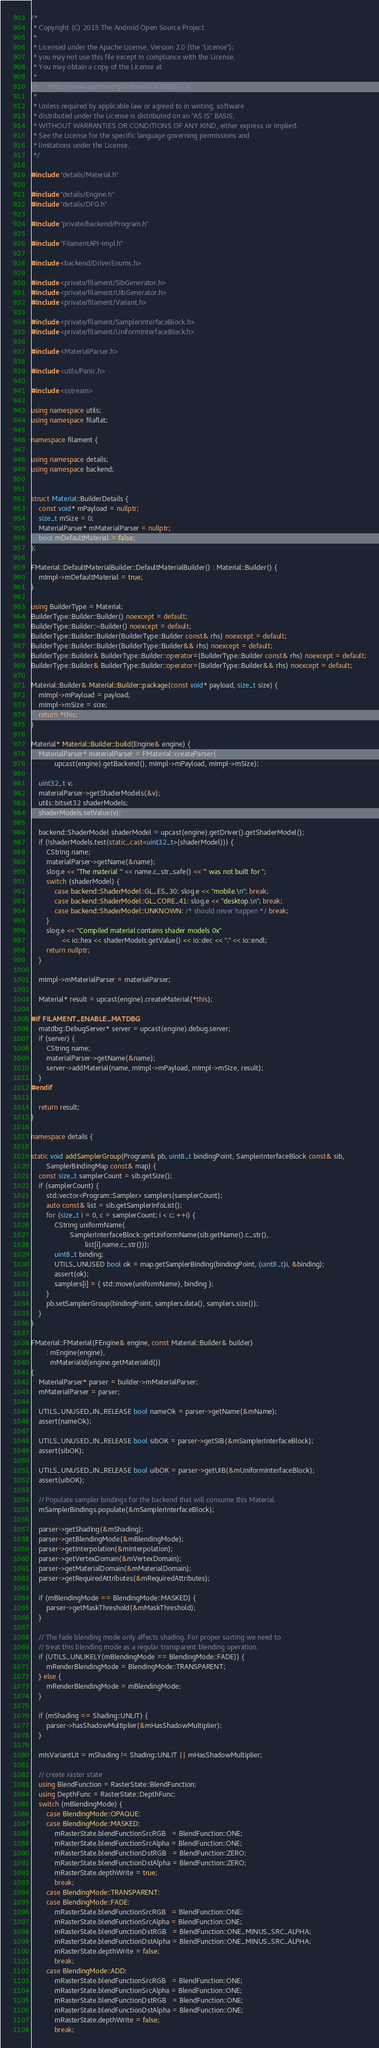<code> <loc_0><loc_0><loc_500><loc_500><_C++_>/*
 * Copyright (C) 2015 The Android Open Source Project
 *
 * Licensed under the Apache License, Version 2.0 (the "License");
 * you may not use this file except in compliance with the License.
 * You may obtain a copy of the License at
 *
 *      http://www.apache.org/licenses/LICENSE-2.0
 *
 * Unless required by applicable law or agreed to in writing, software
 * distributed under the License is distributed on an "AS IS" BASIS,
 * WITHOUT WARRANTIES OR CONDITIONS OF ANY KIND, either express or implied.
 * See the License for the specific language governing permissions and
 * limitations under the License.
 */

#include "details/Material.h"

#include "details/Engine.h"
#include "details/DFG.h"

#include "private/backend/Program.h"

#include "FilamentAPI-impl.h"

#include <backend/DriverEnums.h>

#include <private/filament/SibGenerator.h>
#include <private/filament/UibGenerator.h>
#include <private/filament/Variant.h>

#include <private/filament/SamplerInterfaceBlock.h>
#include <private/filament/UniformInterfaceBlock.h>

#include <MaterialParser.h>

#include <utils/Panic.h>

#include <sstream>

using namespace utils;
using namespace filaflat;

namespace filament {

using namespace details;
using namespace backend;


struct Material::BuilderDetails {
    const void* mPayload = nullptr;
    size_t mSize = 0;
    MaterialParser* mMaterialParser = nullptr;
    bool mDefaultMaterial = false;
};

FMaterial::DefaultMaterialBuilder::DefaultMaterialBuilder() : Material::Builder() {
    mImpl->mDefaultMaterial = true;
}

using BuilderType = Material;
BuilderType::Builder::Builder() noexcept = default;
BuilderType::Builder::~Builder() noexcept = default;
BuilderType::Builder::Builder(BuilderType::Builder const& rhs) noexcept = default;
BuilderType::Builder::Builder(BuilderType::Builder&& rhs) noexcept = default;
BuilderType::Builder& BuilderType::Builder::operator=(BuilderType::Builder const& rhs) noexcept = default;
BuilderType::Builder& BuilderType::Builder::operator=(BuilderType::Builder&& rhs) noexcept = default;

Material::Builder& Material::Builder::package(const void* payload, size_t size) {
    mImpl->mPayload = payload;
    mImpl->mSize = size;
    return *this;
}

Material* Material::Builder::build(Engine& engine) {
    MaterialParser* materialParser = FMaterial::createParser(
            upcast(engine).getBackend(), mImpl->mPayload, mImpl->mSize);

    uint32_t v;
    materialParser->getShaderModels(&v);
    utils::bitset32 shaderModels;
    shaderModels.setValue(v);

    backend::ShaderModel shaderModel = upcast(engine).getDriver().getShaderModel();
    if (!shaderModels.test(static_cast<uint32_t>(shaderModel))) {
        CString name;
        materialParser->getName(&name);
        slog.e << "The material '" << name.c_str_safe() << "' was not built for ";
        switch (shaderModel) {
            case backend::ShaderModel::GL_ES_30: slog.e << "mobile.\n"; break;
            case backend::ShaderModel::GL_CORE_41: slog.e << "desktop.\n"; break;
            case backend::ShaderModel::UNKNOWN: /* should never happen */ break;
        }
        slog.e << "Compiled material contains shader models 0x"
                << io::hex << shaderModels.getValue() << io::dec << "." << io::endl;
        return nullptr;
    }

    mImpl->mMaterialParser = materialParser;

    Material* result = upcast(engine).createMaterial(*this);

#if FILAMENT_ENABLE_MATDBG
    matdbg::DebugServer* server = upcast(engine).debug.server;
    if (server) {
        CString name;
        materialParser->getName(&name);
        server->addMaterial(name, mImpl->mPayload, mImpl->mSize, result);
    }
#endif

    return result;
}

namespace details {

static void addSamplerGroup(Program& pb, uint8_t bindingPoint, SamplerInterfaceBlock const& sib,
        SamplerBindingMap const& map) {
    const size_t samplerCount = sib.getSize();
    if (samplerCount) {
        std::vector<Program::Sampler> samplers(samplerCount);
        auto const& list = sib.getSamplerInfoList();
        for (size_t i = 0, c = samplerCount; i < c; ++i) {
            CString uniformName(
                    SamplerInterfaceBlock::getUniformName(sib.getName().c_str(),
                            list[i].name.c_str()));
            uint8_t binding;
            UTILS_UNUSED bool ok = map.getSamplerBinding(bindingPoint, (uint8_t)i, &binding);
            assert(ok);
            samplers[i] = { std::move(uniformName), binding };
        }
        pb.setSamplerGroup(bindingPoint, samplers.data(), samplers.size());
    }
}

FMaterial::FMaterial(FEngine& engine, const Material::Builder& builder)
        : mEngine(engine),
          mMaterialId(engine.getMaterialId())
{
    MaterialParser* parser = builder->mMaterialParser;
    mMaterialParser = parser;

    UTILS_UNUSED_IN_RELEASE bool nameOk = parser->getName(&mName);
    assert(nameOk);

    UTILS_UNUSED_IN_RELEASE bool sibOK = parser->getSIB(&mSamplerInterfaceBlock);
    assert(sibOK);

    UTILS_UNUSED_IN_RELEASE bool uibOK = parser->getUIB(&mUniformInterfaceBlock);
    assert(uibOK);

    // Populate sampler bindings for the backend that will consume this Material.
    mSamplerBindings.populate(&mSamplerInterfaceBlock);

    parser->getShading(&mShading);
    parser->getBlendingMode(&mBlendingMode);
    parser->getInterpolation(&mInterpolation);
    parser->getVertexDomain(&mVertexDomain);
    parser->getMaterialDomain(&mMaterialDomain);
    parser->getRequiredAttributes(&mRequiredAttributes);

    if (mBlendingMode == BlendingMode::MASKED) {
        parser->getMaskThreshold(&mMaskThreshold);
    }

    // The fade blending mode only affects shading. For proper sorting we need to
    // treat this blending mode as a regular transparent blending operation.
    if (UTILS_UNLIKELY(mBlendingMode == BlendingMode::FADE)) {
        mRenderBlendingMode = BlendingMode::TRANSPARENT;
    } else {
        mRenderBlendingMode = mBlendingMode;
    }

    if (mShading == Shading::UNLIT) {
        parser->hasShadowMultiplier(&mHasShadowMultiplier);
    }

    mIsVariantLit = mShading != Shading::UNLIT || mHasShadowMultiplier;

    // create raster state
    using BlendFunction = RasterState::BlendFunction;
    using DepthFunc = RasterState::DepthFunc;
    switch (mBlendingMode) {
        case BlendingMode::OPAQUE:
        case BlendingMode::MASKED:
            mRasterState.blendFunctionSrcRGB   = BlendFunction::ONE;
            mRasterState.blendFunctionSrcAlpha = BlendFunction::ONE;
            mRasterState.blendFunctionDstRGB   = BlendFunction::ZERO;
            mRasterState.blendFunctionDstAlpha = BlendFunction::ZERO;
            mRasterState.depthWrite = true;
            break;
        case BlendingMode::TRANSPARENT:
        case BlendingMode::FADE:
            mRasterState.blendFunctionSrcRGB   = BlendFunction::ONE;
            mRasterState.blendFunctionSrcAlpha = BlendFunction::ONE;
            mRasterState.blendFunctionDstRGB   = BlendFunction::ONE_MINUS_SRC_ALPHA;
            mRasterState.blendFunctionDstAlpha = BlendFunction::ONE_MINUS_SRC_ALPHA;
            mRasterState.depthWrite = false;
            break;
        case BlendingMode::ADD:
            mRasterState.blendFunctionSrcRGB   = BlendFunction::ONE;
            mRasterState.blendFunctionSrcAlpha = BlendFunction::ONE;
            mRasterState.blendFunctionDstRGB   = BlendFunction::ONE;
            mRasterState.blendFunctionDstAlpha = BlendFunction::ONE;
            mRasterState.depthWrite = false;
            break;</code> 